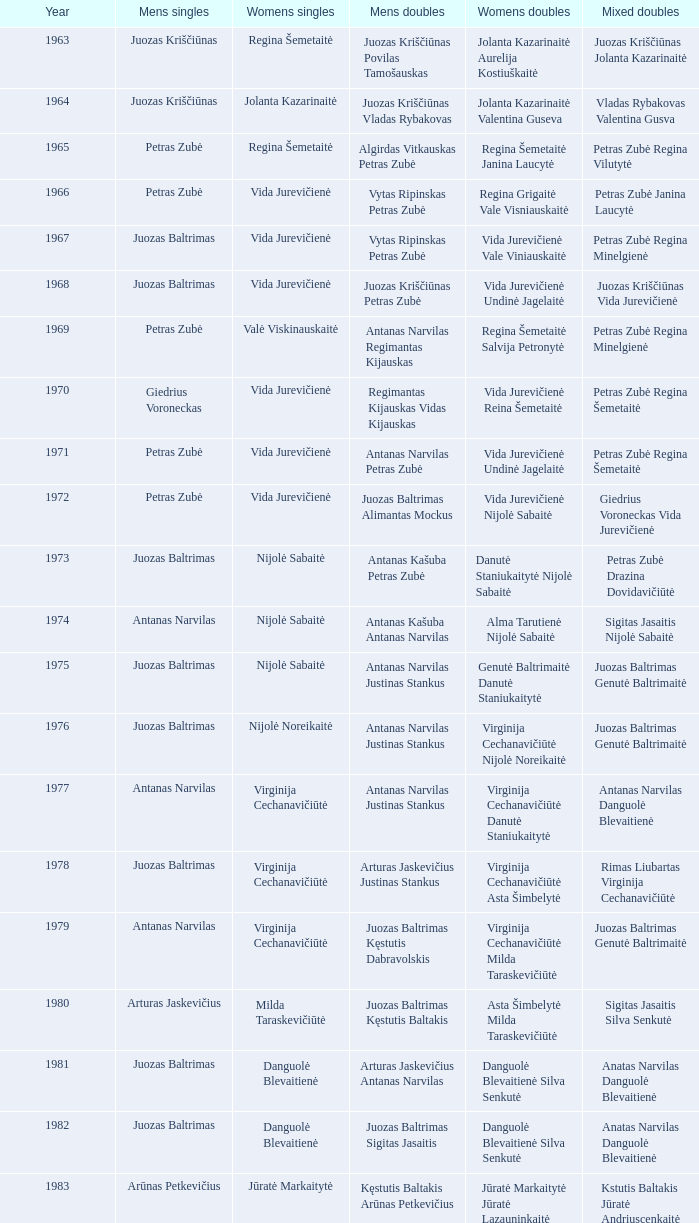What was the first year of the Lithuanian National Badminton Championships? 1963.0. 